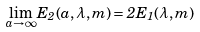<formula> <loc_0><loc_0><loc_500><loc_500>\lim _ { a \to \infty } E _ { 2 } ( a , \lambda , m ) = 2 E _ { 1 } ( \lambda , m )</formula> 